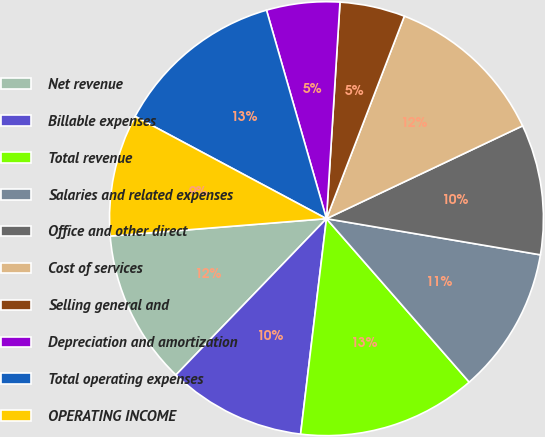Convert chart to OTSL. <chart><loc_0><loc_0><loc_500><loc_500><pie_chart><fcel>Net revenue<fcel>Billable expenses<fcel>Total revenue<fcel>Salaries and related expenses<fcel>Office and other direct<fcel>Cost of services<fcel>Selling general and<fcel>Depreciation and amortization<fcel>Total operating expenses<fcel>OPERATING INCOME<nl><fcel>11.52%<fcel>10.3%<fcel>13.33%<fcel>10.91%<fcel>9.7%<fcel>12.12%<fcel>4.85%<fcel>5.45%<fcel>12.73%<fcel>9.09%<nl></chart> 